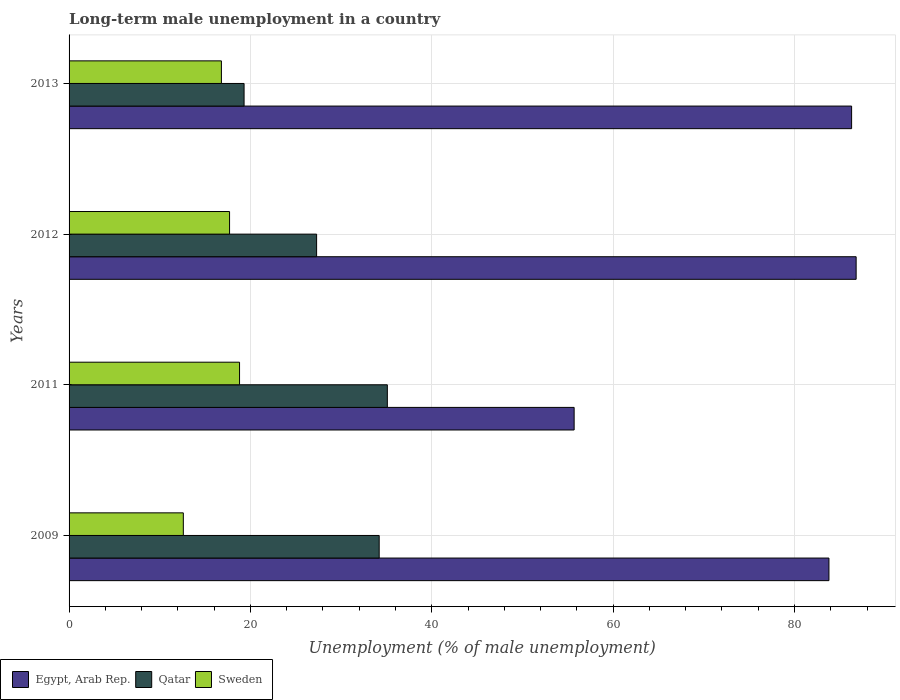How many bars are there on the 1st tick from the top?
Offer a terse response. 3. What is the label of the 3rd group of bars from the top?
Your answer should be very brief. 2011. What is the percentage of long-term unemployed male population in Egypt, Arab Rep. in 2013?
Keep it short and to the point. 86.3. Across all years, what is the maximum percentage of long-term unemployed male population in Qatar?
Give a very brief answer. 35.1. Across all years, what is the minimum percentage of long-term unemployed male population in Sweden?
Your response must be concise. 12.6. What is the total percentage of long-term unemployed male population in Sweden in the graph?
Provide a short and direct response. 65.9. What is the average percentage of long-term unemployed male population in Sweden per year?
Your answer should be compact. 16.47. In the year 2012, what is the difference between the percentage of long-term unemployed male population in Sweden and percentage of long-term unemployed male population in Egypt, Arab Rep.?
Give a very brief answer. -69.1. What is the ratio of the percentage of long-term unemployed male population in Sweden in 2009 to that in 2013?
Give a very brief answer. 0.75. Is the difference between the percentage of long-term unemployed male population in Sweden in 2009 and 2012 greater than the difference between the percentage of long-term unemployed male population in Egypt, Arab Rep. in 2009 and 2012?
Offer a very short reply. No. What is the difference between the highest and the second highest percentage of long-term unemployed male population in Qatar?
Your response must be concise. 0.9. What is the difference between the highest and the lowest percentage of long-term unemployed male population in Qatar?
Offer a terse response. 15.8. Is the sum of the percentage of long-term unemployed male population in Egypt, Arab Rep. in 2009 and 2012 greater than the maximum percentage of long-term unemployed male population in Sweden across all years?
Keep it short and to the point. Yes. What does the 3rd bar from the top in 2012 represents?
Provide a short and direct response. Egypt, Arab Rep. What does the 2nd bar from the bottom in 2011 represents?
Your answer should be very brief. Qatar. Is it the case that in every year, the sum of the percentage of long-term unemployed male population in Qatar and percentage of long-term unemployed male population in Sweden is greater than the percentage of long-term unemployed male population in Egypt, Arab Rep.?
Offer a very short reply. No. How many bars are there?
Your response must be concise. 12. How many years are there in the graph?
Offer a terse response. 4. Does the graph contain any zero values?
Your response must be concise. No. Does the graph contain grids?
Make the answer very short. Yes. How are the legend labels stacked?
Offer a very short reply. Horizontal. What is the title of the graph?
Provide a short and direct response. Long-term male unemployment in a country. What is the label or title of the X-axis?
Offer a terse response. Unemployment (% of male unemployment). What is the label or title of the Y-axis?
Your response must be concise. Years. What is the Unemployment (% of male unemployment) of Egypt, Arab Rep. in 2009?
Make the answer very short. 83.8. What is the Unemployment (% of male unemployment) in Qatar in 2009?
Your response must be concise. 34.2. What is the Unemployment (% of male unemployment) of Sweden in 2009?
Your response must be concise. 12.6. What is the Unemployment (% of male unemployment) in Egypt, Arab Rep. in 2011?
Offer a very short reply. 55.7. What is the Unemployment (% of male unemployment) of Qatar in 2011?
Ensure brevity in your answer.  35.1. What is the Unemployment (% of male unemployment) of Sweden in 2011?
Your response must be concise. 18.8. What is the Unemployment (% of male unemployment) in Egypt, Arab Rep. in 2012?
Your response must be concise. 86.8. What is the Unemployment (% of male unemployment) in Qatar in 2012?
Offer a very short reply. 27.3. What is the Unemployment (% of male unemployment) of Sweden in 2012?
Offer a very short reply. 17.7. What is the Unemployment (% of male unemployment) of Egypt, Arab Rep. in 2013?
Provide a short and direct response. 86.3. What is the Unemployment (% of male unemployment) of Qatar in 2013?
Ensure brevity in your answer.  19.3. What is the Unemployment (% of male unemployment) of Sweden in 2013?
Keep it short and to the point. 16.8. Across all years, what is the maximum Unemployment (% of male unemployment) in Egypt, Arab Rep.?
Offer a very short reply. 86.8. Across all years, what is the maximum Unemployment (% of male unemployment) of Qatar?
Your answer should be compact. 35.1. Across all years, what is the maximum Unemployment (% of male unemployment) in Sweden?
Offer a very short reply. 18.8. Across all years, what is the minimum Unemployment (% of male unemployment) in Egypt, Arab Rep.?
Offer a very short reply. 55.7. Across all years, what is the minimum Unemployment (% of male unemployment) of Qatar?
Offer a very short reply. 19.3. Across all years, what is the minimum Unemployment (% of male unemployment) of Sweden?
Offer a very short reply. 12.6. What is the total Unemployment (% of male unemployment) in Egypt, Arab Rep. in the graph?
Provide a succinct answer. 312.6. What is the total Unemployment (% of male unemployment) in Qatar in the graph?
Make the answer very short. 115.9. What is the total Unemployment (% of male unemployment) in Sweden in the graph?
Ensure brevity in your answer.  65.9. What is the difference between the Unemployment (% of male unemployment) in Egypt, Arab Rep. in 2009 and that in 2011?
Offer a very short reply. 28.1. What is the difference between the Unemployment (% of male unemployment) of Qatar in 2009 and that in 2011?
Your answer should be compact. -0.9. What is the difference between the Unemployment (% of male unemployment) of Sweden in 2009 and that in 2011?
Your answer should be very brief. -6.2. What is the difference between the Unemployment (% of male unemployment) in Qatar in 2009 and that in 2013?
Give a very brief answer. 14.9. What is the difference between the Unemployment (% of male unemployment) in Sweden in 2009 and that in 2013?
Offer a very short reply. -4.2. What is the difference between the Unemployment (% of male unemployment) of Egypt, Arab Rep. in 2011 and that in 2012?
Offer a terse response. -31.1. What is the difference between the Unemployment (% of male unemployment) in Qatar in 2011 and that in 2012?
Give a very brief answer. 7.8. What is the difference between the Unemployment (% of male unemployment) in Egypt, Arab Rep. in 2011 and that in 2013?
Give a very brief answer. -30.6. What is the difference between the Unemployment (% of male unemployment) in Sweden in 2012 and that in 2013?
Keep it short and to the point. 0.9. What is the difference between the Unemployment (% of male unemployment) of Egypt, Arab Rep. in 2009 and the Unemployment (% of male unemployment) of Qatar in 2011?
Your answer should be compact. 48.7. What is the difference between the Unemployment (% of male unemployment) of Egypt, Arab Rep. in 2009 and the Unemployment (% of male unemployment) of Qatar in 2012?
Offer a very short reply. 56.5. What is the difference between the Unemployment (% of male unemployment) of Egypt, Arab Rep. in 2009 and the Unemployment (% of male unemployment) of Sweden in 2012?
Your response must be concise. 66.1. What is the difference between the Unemployment (% of male unemployment) of Egypt, Arab Rep. in 2009 and the Unemployment (% of male unemployment) of Qatar in 2013?
Make the answer very short. 64.5. What is the difference between the Unemployment (% of male unemployment) of Qatar in 2009 and the Unemployment (% of male unemployment) of Sweden in 2013?
Provide a short and direct response. 17.4. What is the difference between the Unemployment (% of male unemployment) of Egypt, Arab Rep. in 2011 and the Unemployment (% of male unemployment) of Qatar in 2012?
Offer a terse response. 28.4. What is the difference between the Unemployment (% of male unemployment) of Egypt, Arab Rep. in 2011 and the Unemployment (% of male unemployment) of Sweden in 2012?
Your answer should be very brief. 38. What is the difference between the Unemployment (% of male unemployment) of Qatar in 2011 and the Unemployment (% of male unemployment) of Sweden in 2012?
Your answer should be compact. 17.4. What is the difference between the Unemployment (% of male unemployment) in Egypt, Arab Rep. in 2011 and the Unemployment (% of male unemployment) in Qatar in 2013?
Provide a succinct answer. 36.4. What is the difference between the Unemployment (% of male unemployment) in Egypt, Arab Rep. in 2011 and the Unemployment (% of male unemployment) in Sweden in 2013?
Provide a succinct answer. 38.9. What is the difference between the Unemployment (% of male unemployment) of Egypt, Arab Rep. in 2012 and the Unemployment (% of male unemployment) of Qatar in 2013?
Provide a succinct answer. 67.5. What is the difference between the Unemployment (% of male unemployment) of Egypt, Arab Rep. in 2012 and the Unemployment (% of male unemployment) of Sweden in 2013?
Offer a terse response. 70. What is the difference between the Unemployment (% of male unemployment) in Qatar in 2012 and the Unemployment (% of male unemployment) in Sweden in 2013?
Give a very brief answer. 10.5. What is the average Unemployment (% of male unemployment) in Egypt, Arab Rep. per year?
Offer a terse response. 78.15. What is the average Unemployment (% of male unemployment) in Qatar per year?
Provide a short and direct response. 28.98. What is the average Unemployment (% of male unemployment) of Sweden per year?
Make the answer very short. 16.48. In the year 2009, what is the difference between the Unemployment (% of male unemployment) in Egypt, Arab Rep. and Unemployment (% of male unemployment) in Qatar?
Offer a very short reply. 49.6. In the year 2009, what is the difference between the Unemployment (% of male unemployment) of Egypt, Arab Rep. and Unemployment (% of male unemployment) of Sweden?
Your response must be concise. 71.2. In the year 2009, what is the difference between the Unemployment (% of male unemployment) in Qatar and Unemployment (% of male unemployment) in Sweden?
Your answer should be compact. 21.6. In the year 2011, what is the difference between the Unemployment (% of male unemployment) in Egypt, Arab Rep. and Unemployment (% of male unemployment) in Qatar?
Make the answer very short. 20.6. In the year 2011, what is the difference between the Unemployment (% of male unemployment) of Egypt, Arab Rep. and Unemployment (% of male unemployment) of Sweden?
Your response must be concise. 36.9. In the year 2011, what is the difference between the Unemployment (% of male unemployment) in Qatar and Unemployment (% of male unemployment) in Sweden?
Offer a terse response. 16.3. In the year 2012, what is the difference between the Unemployment (% of male unemployment) of Egypt, Arab Rep. and Unemployment (% of male unemployment) of Qatar?
Your response must be concise. 59.5. In the year 2012, what is the difference between the Unemployment (% of male unemployment) in Egypt, Arab Rep. and Unemployment (% of male unemployment) in Sweden?
Provide a succinct answer. 69.1. In the year 2013, what is the difference between the Unemployment (% of male unemployment) of Egypt, Arab Rep. and Unemployment (% of male unemployment) of Qatar?
Your answer should be very brief. 67. In the year 2013, what is the difference between the Unemployment (% of male unemployment) of Egypt, Arab Rep. and Unemployment (% of male unemployment) of Sweden?
Ensure brevity in your answer.  69.5. What is the ratio of the Unemployment (% of male unemployment) in Egypt, Arab Rep. in 2009 to that in 2011?
Your answer should be very brief. 1.5. What is the ratio of the Unemployment (% of male unemployment) of Qatar in 2009 to that in 2011?
Give a very brief answer. 0.97. What is the ratio of the Unemployment (% of male unemployment) of Sweden in 2009 to that in 2011?
Keep it short and to the point. 0.67. What is the ratio of the Unemployment (% of male unemployment) in Egypt, Arab Rep. in 2009 to that in 2012?
Provide a succinct answer. 0.97. What is the ratio of the Unemployment (% of male unemployment) in Qatar in 2009 to that in 2012?
Provide a short and direct response. 1.25. What is the ratio of the Unemployment (% of male unemployment) of Sweden in 2009 to that in 2012?
Your answer should be compact. 0.71. What is the ratio of the Unemployment (% of male unemployment) in Egypt, Arab Rep. in 2009 to that in 2013?
Provide a short and direct response. 0.97. What is the ratio of the Unemployment (% of male unemployment) of Qatar in 2009 to that in 2013?
Your answer should be compact. 1.77. What is the ratio of the Unemployment (% of male unemployment) in Sweden in 2009 to that in 2013?
Your answer should be compact. 0.75. What is the ratio of the Unemployment (% of male unemployment) of Egypt, Arab Rep. in 2011 to that in 2012?
Make the answer very short. 0.64. What is the ratio of the Unemployment (% of male unemployment) in Qatar in 2011 to that in 2012?
Make the answer very short. 1.29. What is the ratio of the Unemployment (% of male unemployment) in Sweden in 2011 to that in 2012?
Offer a very short reply. 1.06. What is the ratio of the Unemployment (% of male unemployment) in Egypt, Arab Rep. in 2011 to that in 2013?
Provide a short and direct response. 0.65. What is the ratio of the Unemployment (% of male unemployment) of Qatar in 2011 to that in 2013?
Your answer should be compact. 1.82. What is the ratio of the Unemployment (% of male unemployment) of Sweden in 2011 to that in 2013?
Keep it short and to the point. 1.12. What is the ratio of the Unemployment (% of male unemployment) of Egypt, Arab Rep. in 2012 to that in 2013?
Keep it short and to the point. 1.01. What is the ratio of the Unemployment (% of male unemployment) in Qatar in 2012 to that in 2013?
Provide a succinct answer. 1.41. What is the ratio of the Unemployment (% of male unemployment) of Sweden in 2012 to that in 2013?
Your response must be concise. 1.05. What is the difference between the highest and the second highest Unemployment (% of male unemployment) of Sweden?
Your answer should be compact. 1.1. What is the difference between the highest and the lowest Unemployment (% of male unemployment) in Egypt, Arab Rep.?
Make the answer very short. 31.1. 